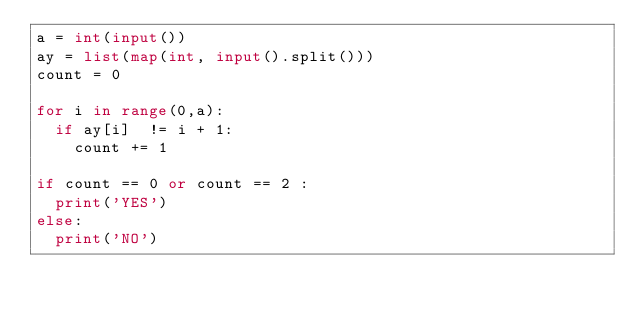<code> <loc_0><loc_0><loc_500><loc_500><_Python_>a = int(input())
ay = list(map(int, input().split()))
count = 0 

for i in range(0,a):
  if ay[i]  != i + 1:
    count += 1

if count == 0 or count == 2 :
  print('YES')
else:
  print('NO')</code> 